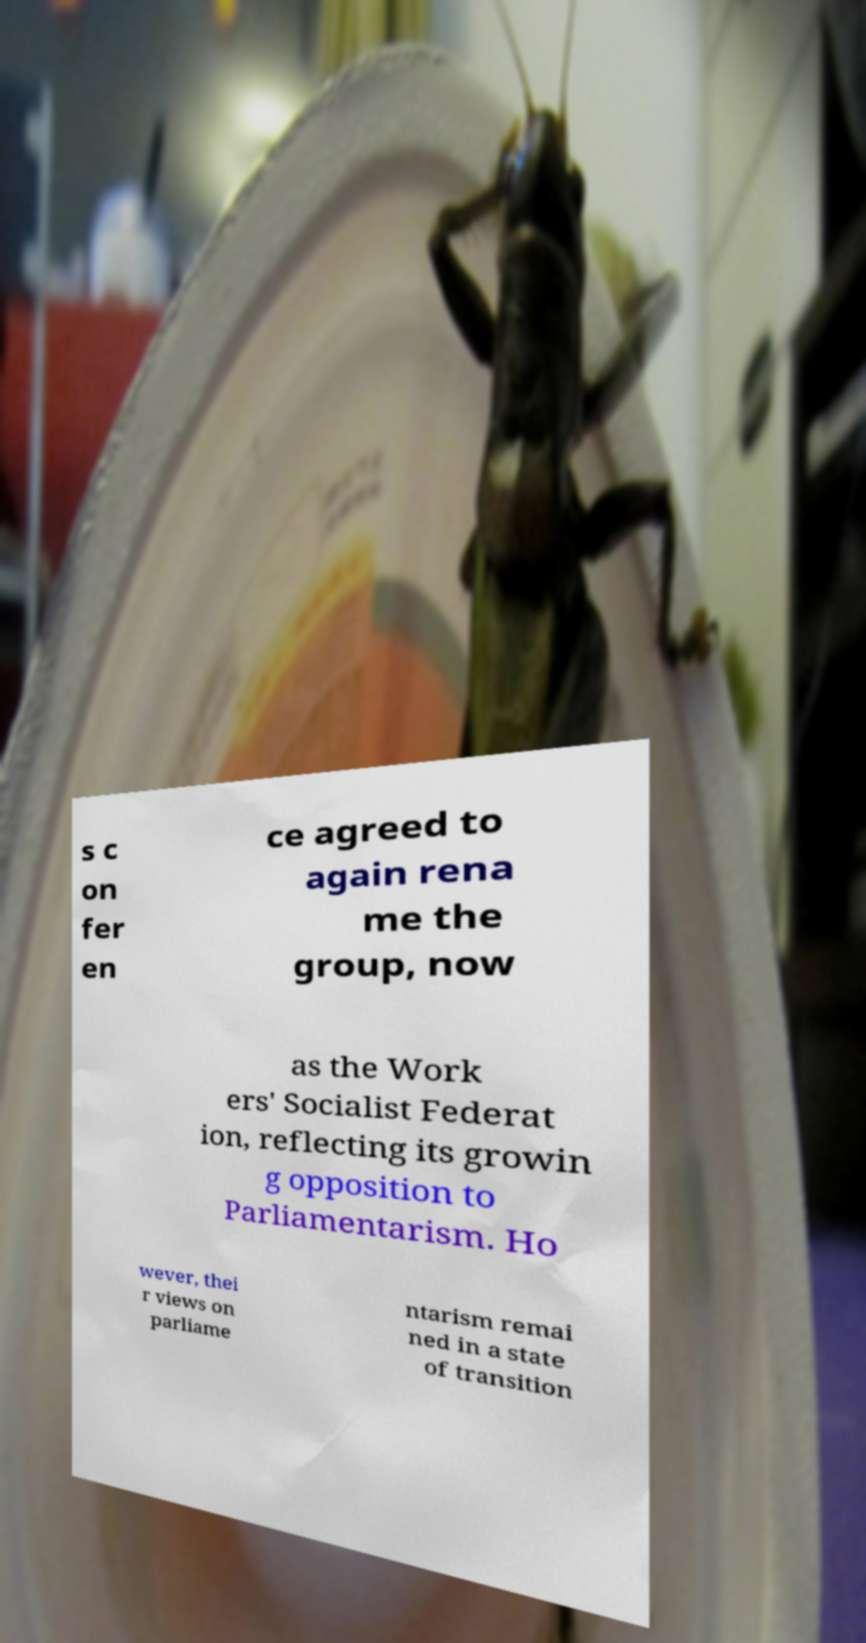I need the written content from this picture converted into text. Can you do that? s c on fer en ce agreed to again rena me the group, now as the Work ers' Socialist Federat ion, reflecting its growin g opposition to Parliamentarism. Ho wever, thei r views on parliame ntarism remai ned in a state of transition 